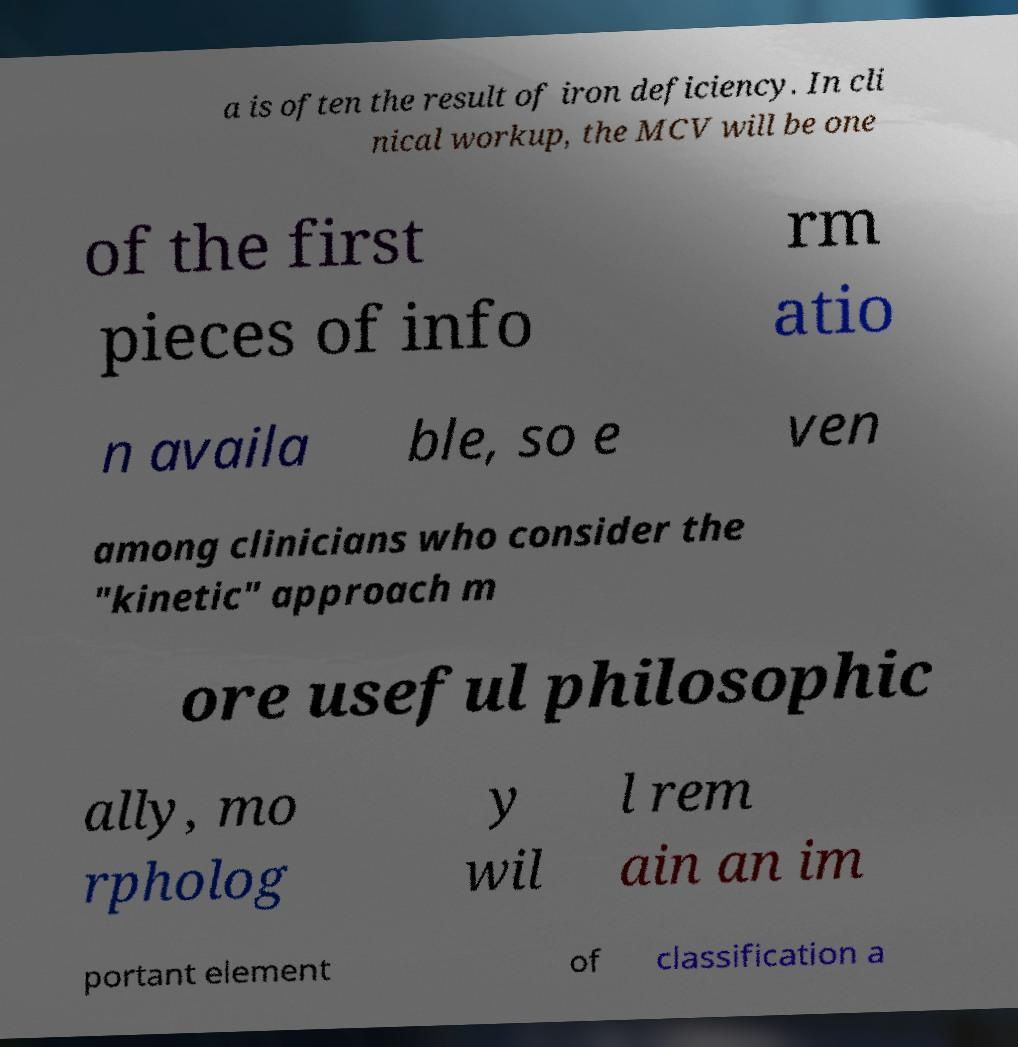Please identify and transcribe the text found in this image. a is often the result of iron deficiency. In cli nical workup, the MCV will be one of the first pieces of info rm atio n availa ble, so e ven among clinicians who consider the "kinetic" approach m ore useful philosophic ally, mo rpholog y wil l rem ain an im portant element of classification a 